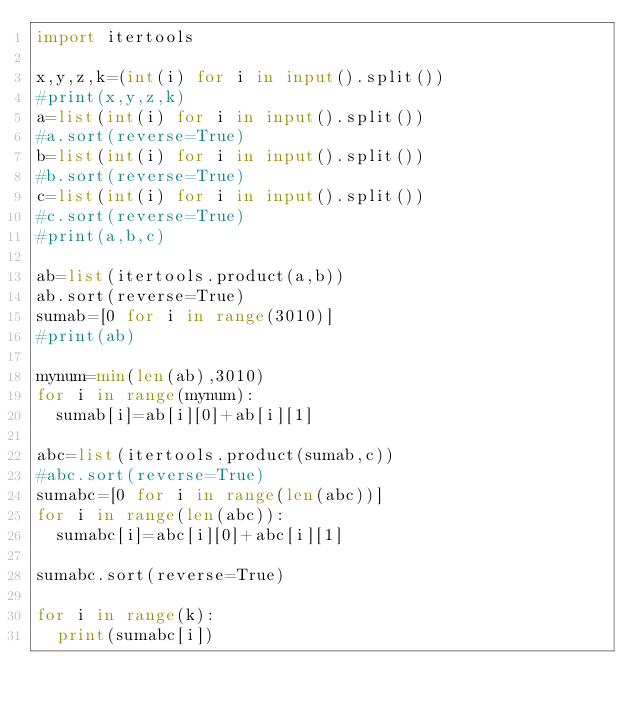<code> <loc_0><loc_0><loc_500><loc_500><_Python_>import itertools

x,y,z,k=(int(i) for i in input().split())
#print(x,y,z,k)
a=list(int(i) for i in input().split())
#a.sort(reverse=True)
b=list(int(i) for i in input().split())
#b.sort(reverse=True)
c=list(int(i) for i in input().split())
#c.sort(reverse=True)
#print(a,b,c)

ab=list(itertools.product(a,b))
ab.sort(reverse=True)
sumab=[0 for i in range(3010)]
#print(ab)

mynum=min(len(ab),3010)
for i in range(mynum):
  sumab[i]=ab[i][0]+ab[i][1]
  
abc=list(itertools.product(sumab,c))
#abc.sort(reverse=True)
sumabc=[0 for i in range(len(abc))]
for i in range(len(abc)):
  sumabc[i]=abc[i][0]+abc[i][1]
  
sumabc.sort(reverse=True)

for i in range(k):
  print(sumabc[i])
  </code> 